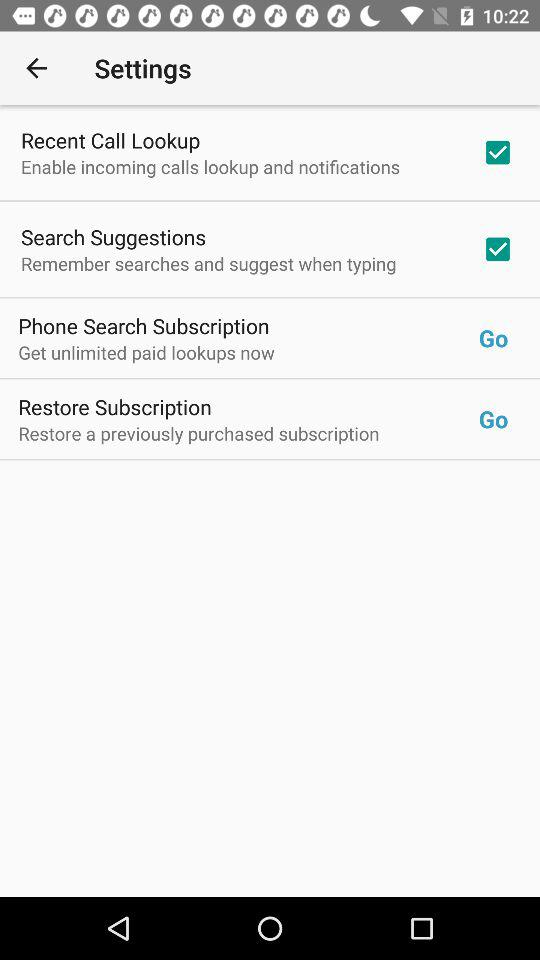What is the status of the "Recent Call Lookup"? The status of the "Recent Call Lookup" is "on". 